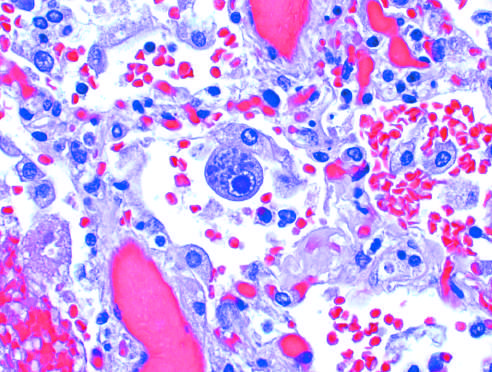re the effector arms of these central circuits seen in an enlarged cell?
Answer the question using a single word or phrase. No 